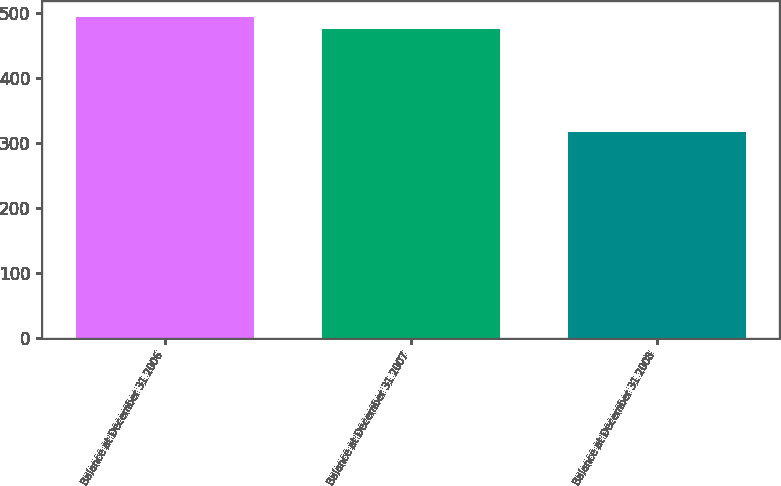Convert chart to OTSL. <chart><loc_0><loc_0><loc_500><loc_500><bar_chart><fcel>Balance at December 31 2006<fcel>Balance at December 31 2007<fcel>Balance at December 31 2008<nl><fcel>493.4<fcel>476<fcel>317<nl></chart> 